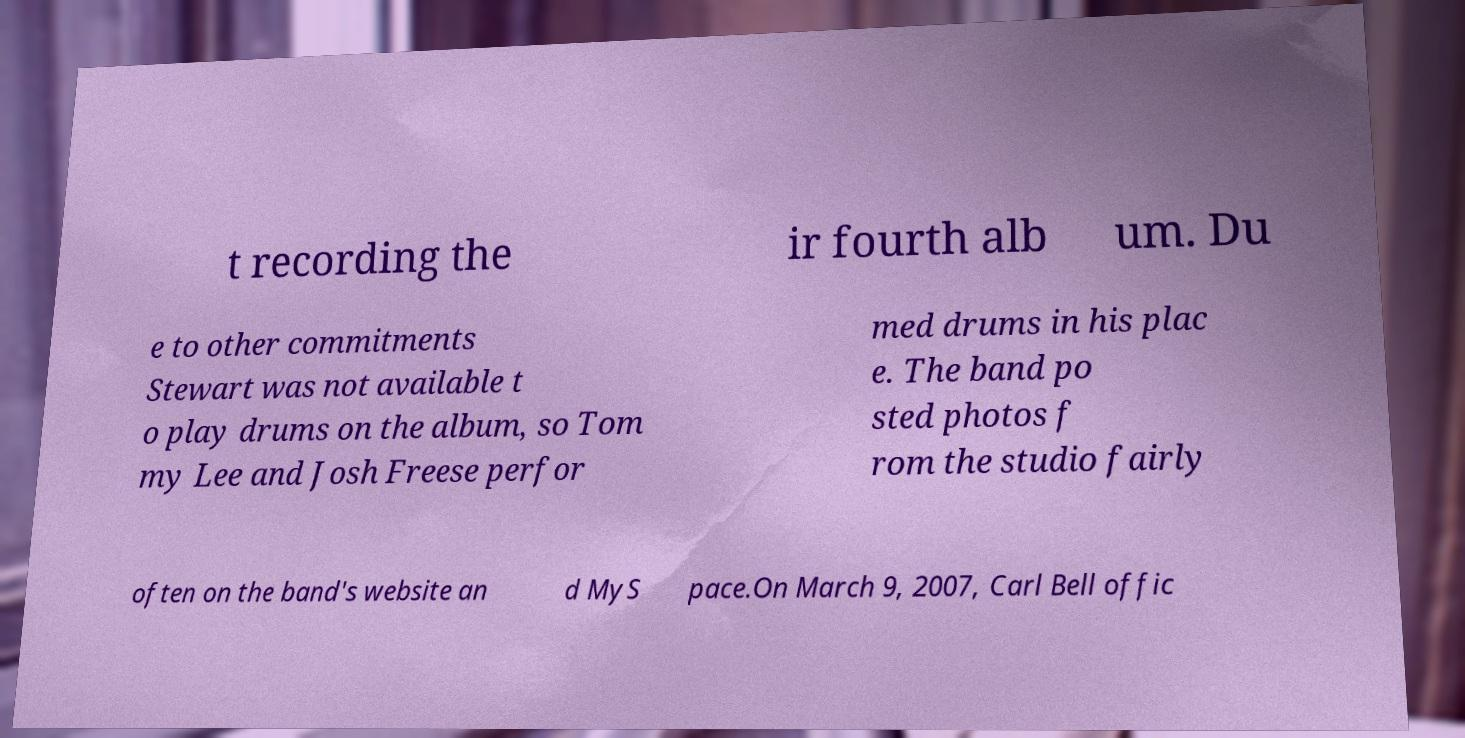There's text embedded in this image that I need extracted. Can you transcribe it verbatim? t recording the ir fourth alb um. Du e to other commitments Stewart was not available t o play drums on the album, so Tom my Lee and Josh Freese perfor med drums in his plac e. The band po sted photos f rom the studio fairly often on the band's website an d MyS pace.On March 9, 2007, Carl Bell offic 